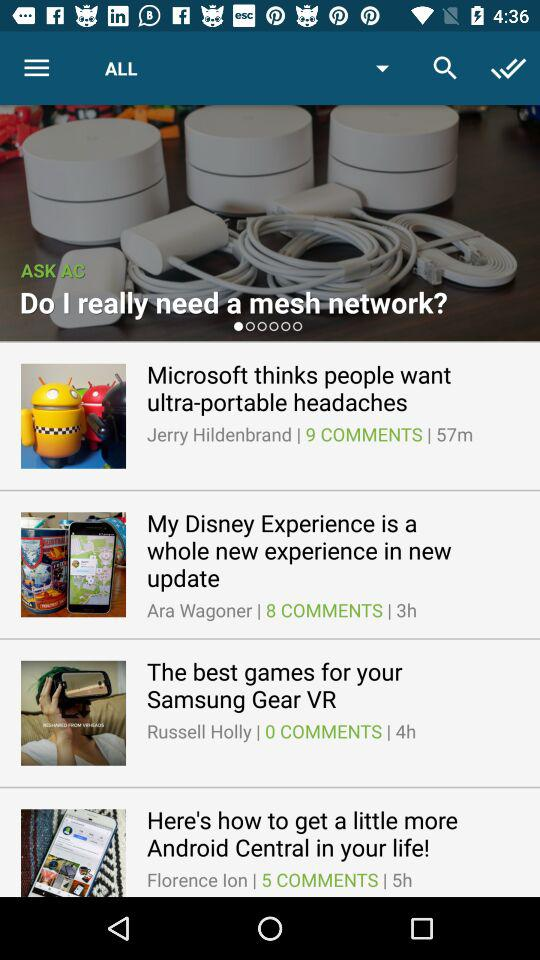Who's the content writer of "The best games for your Samsung Gear VR"? The content writer is Russell Holly. 